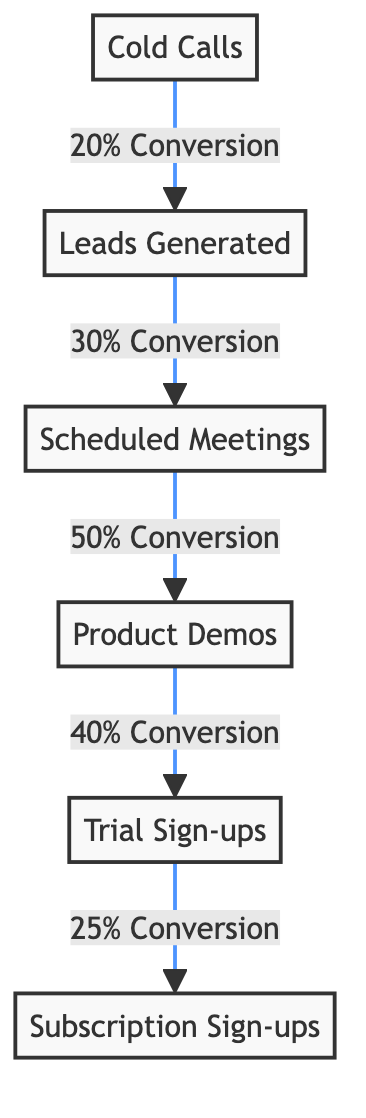What is the conversion rate from Cold Calls to Leads Generated? The diagram indicates a conversion rate of 20% from Cold Calls (A) to Leads Generated (B). This is shown directly on the arrow linking the two nodes.
Answer: 20% How many nodes are in the diagram? The diagram contains six nodes: Cold Calls, Leads Generated, Scheduled Meetings, Product Demos, Trial Sign-ups, and Subscription Sign-ups.
Answer: 6 What is the conversion rate from Product Demos to Trial Sign-ups? According to the diagram, the conversion rate from Product Demos (D) to Trial Sign-ups (E) is 40%, as indicated on the arrow between those two nodes.
Answer: 40% What is the overall conversion rate from Cold Calls to Subscription Sign-ups? To calculate this, you multiply the conversion rates along the path: 20% from Cold Calls to Leads, 30% from Leads to Meetings, 50% from Meetings to Demos, 40% from Demos to Trials, and 25% from Trials to Sign-ups. The overall conversion rate is 20% * 30% * 50% * 40% * 25% = 0.03 or 3%.
Answer: 3% What node follows Scheduled Meetings in the flow? In the flow, Scheduled Meetings (C) is followed by Product Demos (D) as indicated by the arrow connecting these two nodes.
Answer: Product Demos How many conversion rates are shown in the diagram? The diagram displays five conversion rates: from Cold Calls to Leads, Leads to Meetings, Meetings to Demos, Demos to Trials, and Trials to Sign-ups, which totals to five distinct conversion rates.
Answer: 5 What is the conversion rate from Trial Sign-ups to Subscription Sign-ups? The diagram indicates a conversion rate of 25% from Trial Sign-ups (E) to Subscription Sign-ups (F), which is specifically noted along the link between these nodes.
Answer: 25% Which node has the highest conversion rate? The highest conversion rate in the diagram is 50%, occurring from Scheduled Meetings (C) to Product Demos (D), as shown on the connecting arrow.
Answer: 50% 